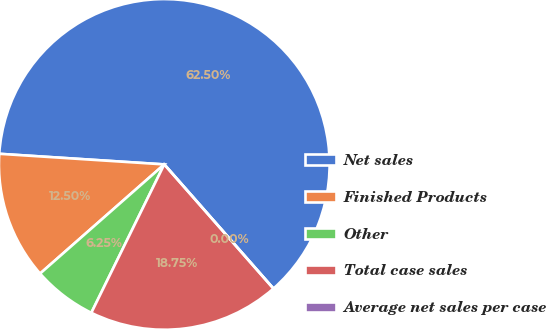Convert chart. <chart><loc_0><loc_0><loc_500><loc_500><pie_chart><fcel>Net sales<fcel>Finished Products<fcel>Other<fcel>Total case sales<fcel>Average net sales per case<nl><fcel>62.5%<fcel>12.5%<fcel>6.25%<fcel>18.75%<fcel>0.0%<nl></chart> 